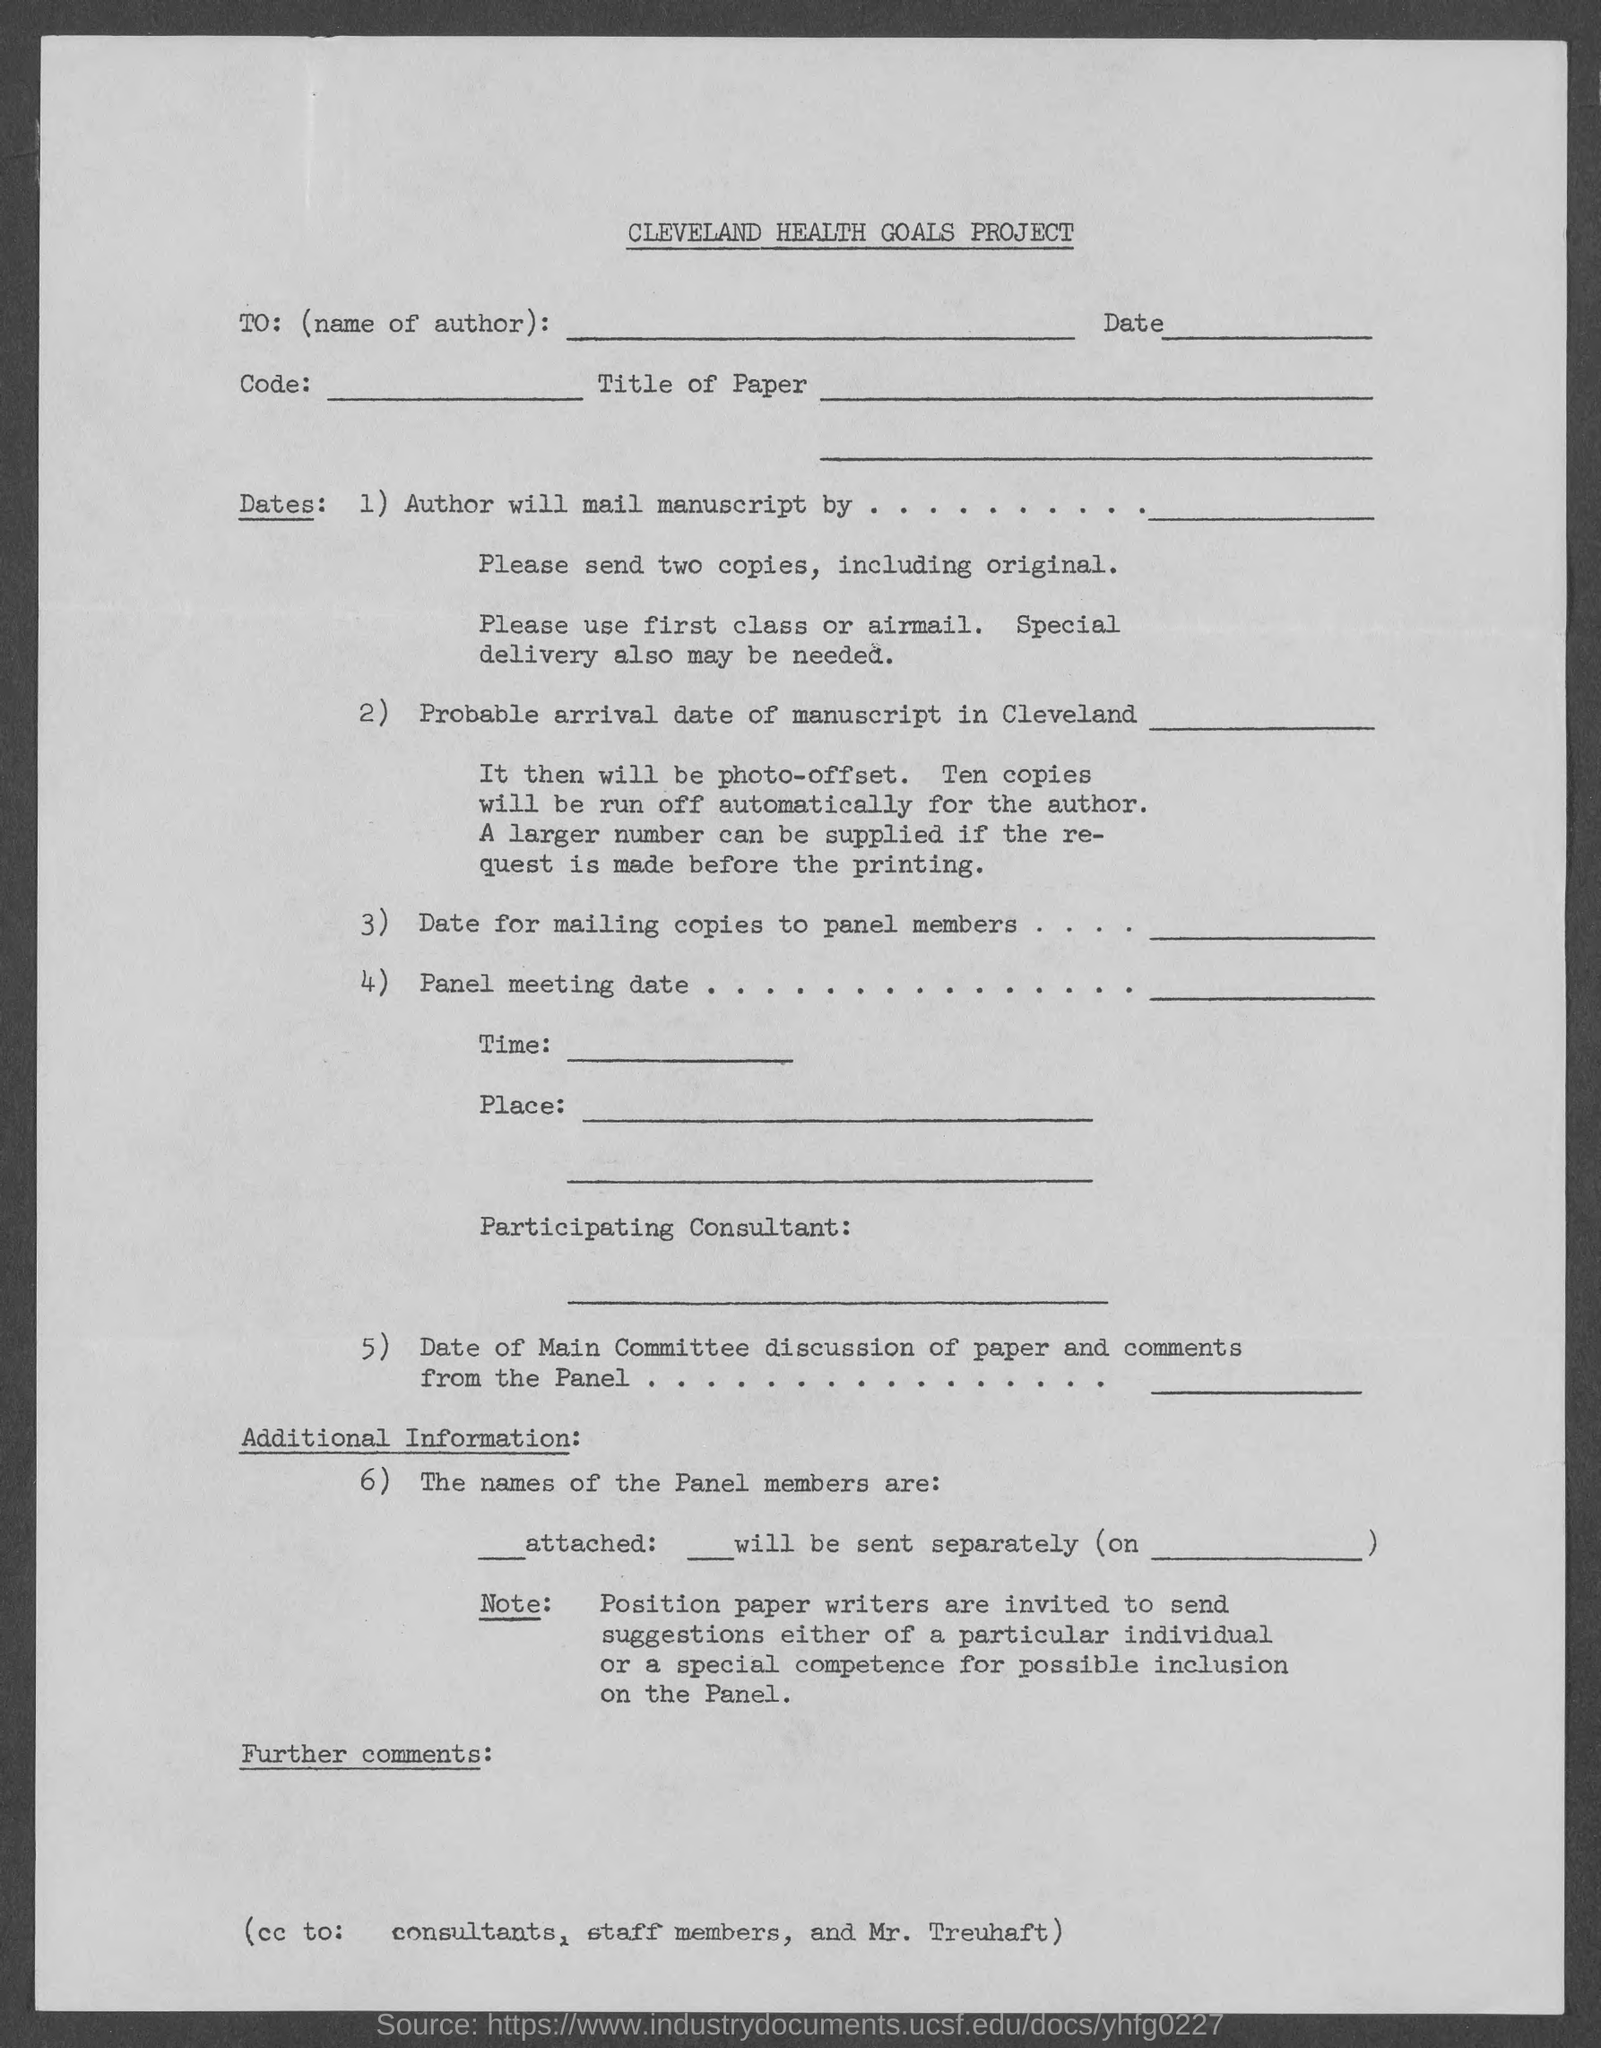Identify some key points in this picture. The abbreviation "TO" at the beginning of a document typically represents the name of the author. The heading of the document is the Cleveland Health Goals Project. 